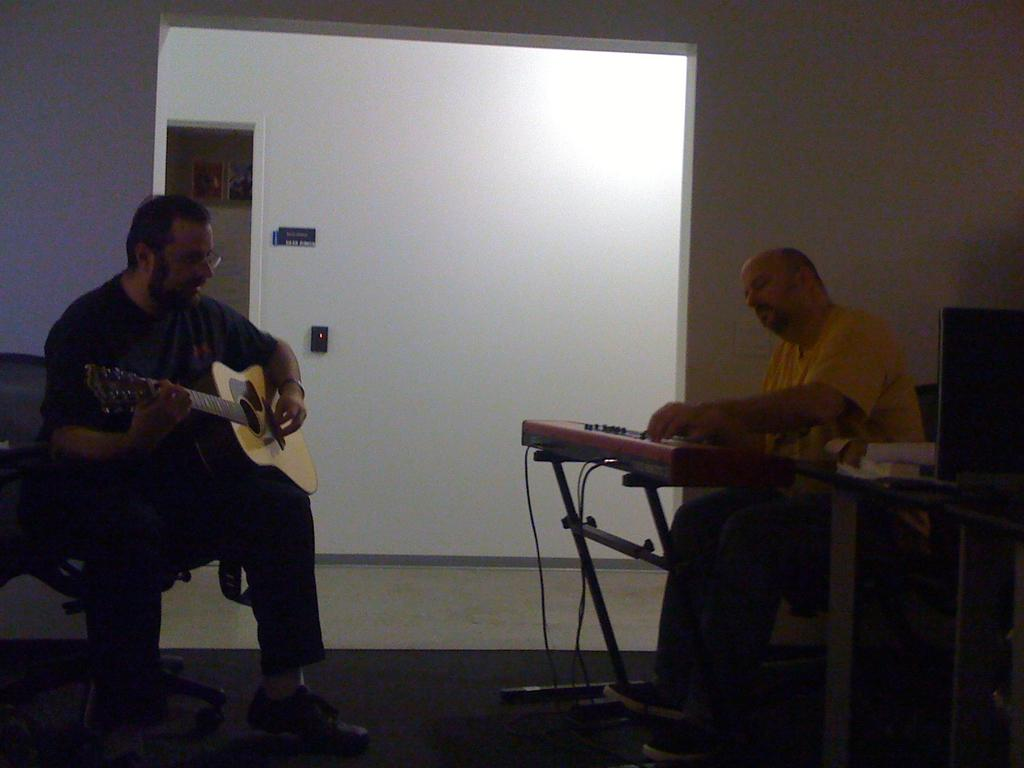How many people are in the image? There are two persons in the image. What are the two persons doing? One person is playing the guitar, and another person is playing the keyboard. What type of coast can be seen in the background of the image? There is no coast visible in the image; it features two people playing musical instruments. What year was the match between these two musicians held? There is no match or competition depicted in the image, so it is not possible to determine the year. 